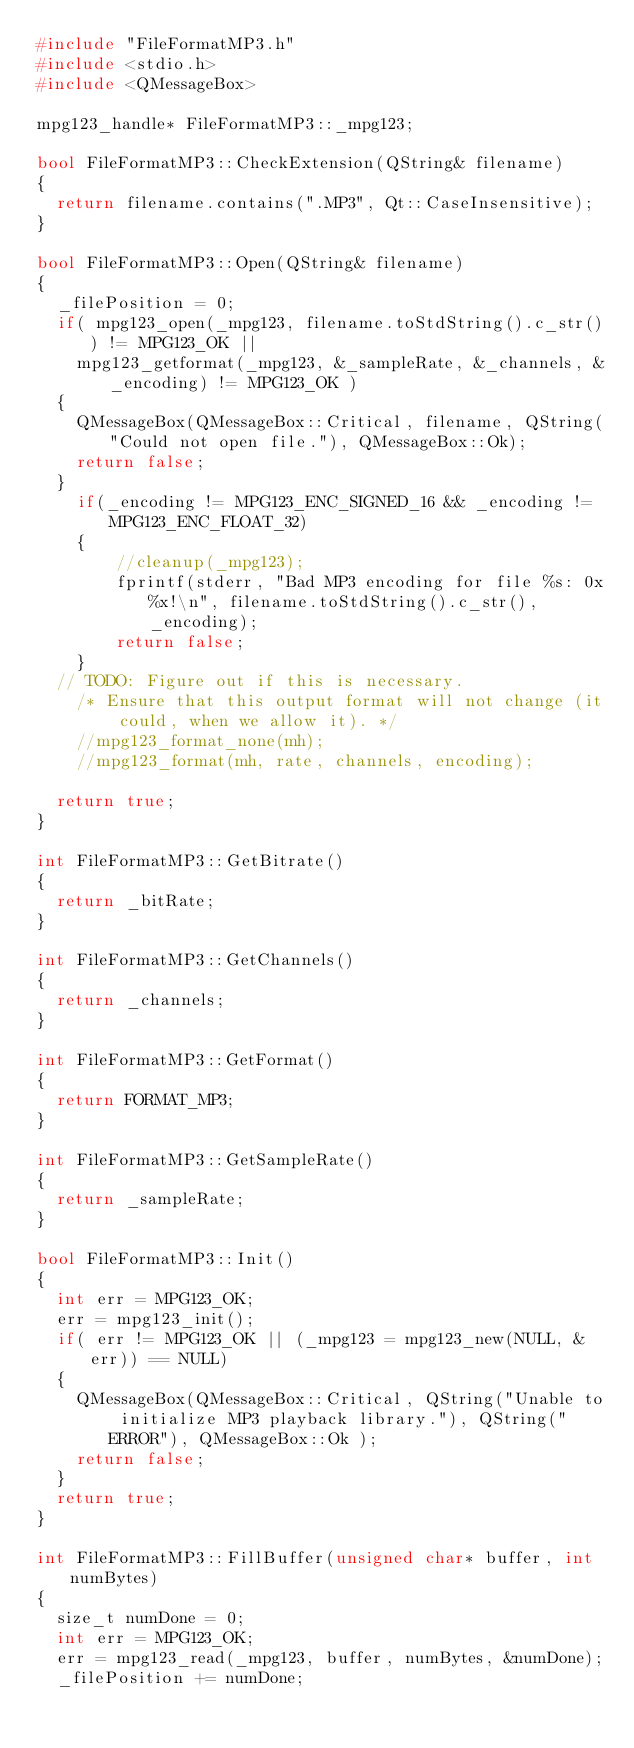<code> <loc_0><loc_0><loc_500><loc_500><_C++_>#include "FileFormatMP3.h"
#include <stdio.h>
#include <QMessageBox>

mpg123_handle* FileFormatMP3::_mpg123;

bool FileFormatMP3::CheckExtension(QString& filename)
{
	return filename.contains(".MP3", Qt::CaseInsensitive);
}

bool FileFormatMP3::Open(QString& filename)
{
	_filePosition = 0;
	if( mpg123_open(_mpg123, filename.toStdString().c_str()) != MPG123_OK ||
		mpg123_getformat(_mpg123, &_sampleRate, &_channels, &_encoding) != MPG123_OK )
	{
		QMessageBox(QMessageBox::Critical, filename, QString("Could not open file."), QMessageBox::Ok);
		return false;
	}
    if(_encoding != MPG123_ENC_SIGNED_16 && _encoding != MPG123_ENC_FLOAT_32)
    {
        //cleanup(_mpg123);
        fprintf(stderr, "Bad MP3 encoding for file %s: 0x%x!\n", filename.toStdString().c_str(), _encoding);
        return false;
    }
	// TODO: Figure out if this is necessary.
    /* Ensure that this output format will not change (it could, when we allow it). */
    //mpg123_format_none(mh);
    //mpg123_format(mh, rate, channels, encoding);

	return true;
}

int FileFormatMP3::GetBitrate()
{
	return _bitRate;
}

int FileFormatMP3::GetChannels()
{
	return _channels;
}

int FileFormatMP3::GetFormat()
{
	return FORMAT_MP3;
}

int FileFormatMP3::GetSampleRate()
{
	return _sampleRate;
}

bool FileFormatMP3::Init()
{
	int err = MPG123_OK;
	err = mpg123_init();
	if( err != MPG123_OK || (_mpg123 = mpg123_new(NULL, &err)) == NULL)
	{
		QMessageBox(QMessageBox::Critical, QString("Unable to initialize MP3 playback library."), QString("ERROR"), QMessageBox::Ok );
		return false;
	}
	return true;
}

int FileFormatMP3::FillBuffer(unsigned char* buffer, int numBytes)
{
	size_t numDone = 0;
	int err = MPG123_OK;
	err = mpg123_read(_mpg123, buffer, numBytes, &numDone);
	_filePosition += numDone;</code> 